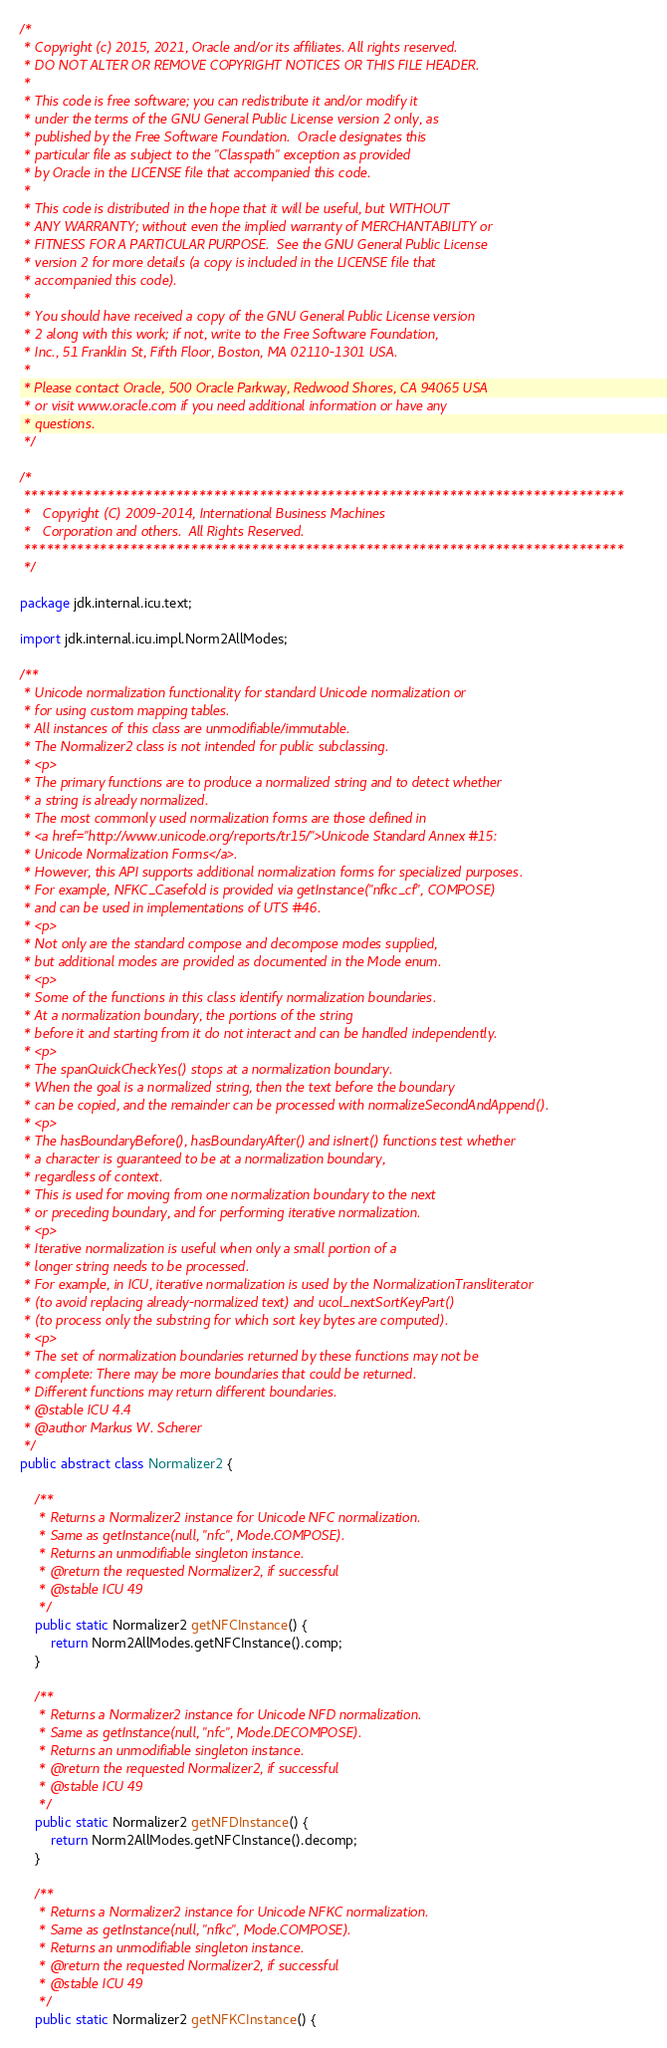Convert code to text. <code><loc_0><loc_0><loc_500><loc_500><_Java_>/*
 * Copyright (c) 2015, 2021, Oracle and/or its affiliates. All rights reserved.
 * DO NOT ALTER OR REMOVE COPYRIGHT NOTICES OR THIS FILE HEADER.
 *
 * This code is free software; you can redistribute it and/or modify it
 * under the terms of the GNU General Public License version 2 only, as
 * published by the Free Software Foundation.  Oracle designates this
 * particular file as subject to the "Classpath" exception as provided
 * by Oracle in the LICENSE file that accompanied this code.
 *
 * This code is distributed in the hope that it will be useful, but WITHOUT
 * ANY WARRANTY; without even the implied warranty of MERCHANTABILITY or
 * FITNESS FOR A PARTICULAR PURPOSE.  See the GNU General Public License
 * version 2 for more details (a copy is included in the LICENSE file that
 * accompanied this code).
 *
 * You should have received a copy of the GNU General Public License version
 * 2 along with this work; if not, write to the Free Software Foundation,
 * Inc., 51 Franklin St, Fifth Floor, Boston, MA 02110-1301 USA.
 *
 * Please contact Oracle, 500 Oracle Parkway, Redwood Shores, CA 94065 USA
 * or visit www.oracle.com if you need additional information or have any
 * questions.
 */

/*
 *******************************************************************************
 *   Copyright (C) 2009-2014, International Business Machines
 *   Corporation and others.  All Rights Reserved.
 *******************************************************************************
 */

package jdk.internal.icu.text;

import jdk.internal.icu.impl.Norm2AllModes;

/**
 * Unicode normalization functionality for standard Unicode normalization or
 * for using custom mapping tables.
 * All instances of this class are unmodifiable/immutable.
 * The Normalizer2 class is not intended for public subclassing.
 * <p>
 * The primary functions are to produce a normalized string and to detect whether
 * a string is already normalized.
 * The most commonly used normalization forms are those defined in
 * <a href="http://www.unicode.org/reports/tr15/">Unicode Standard Annex #15:
 * Unicode Normalization Forms</a>.
 * However, this API supports additional normalization forms for specialized purposes.
 * For example, NFKC_Casefold is provided via getInstance("nfkc_cf", COMPOSE)
 * and can be used in implementations of UTS #46.
 * <p>
 * Not only are the standard compose and decompose modes supplied,
 * but additional modes are provided as documented in the Mode enum.
 * <p>
 * Some of the functions in this class identify normalization boundaries.
 * At a normalization boundary, the portions of the string
 * before it and starting from it do not interact and can be handled independently.
 * <p>
 * The spanQuickCheckYes() stops at a normalization boundary.
 * When the goal is a normalized string, then the text before the boundary
 * can be copied, and the remainder can be processed with normalizeSecondAndAppend().
 * <p>
 * The hasBoundaryBefore(), hasBoundaryAfter() and isInert() functions test whether
 * a character is guaranteed to be at a normalization boundary,
 * regardless of context.
 * This is used for moving from one normalization boundary to the next
 * or preceding boundary, and for performing iterative normalization.
 * <p>
 * Iterative normalization is useful when only a small portion of a
 * longer string needs to be processed.
 * For example, in ICU, iterative normalization is used by the NormalizationTransliterator
 * (to avoid replacing already-normalized text) and ucol_nextSortKeyPart()
 * (to process only the substring for which sort key bytes are computed).
 * <p>
 * The set of normalization boundaries returned by these functions may not be
 * complete: There may be more boundaries that could be returned.
 * Different functions may return different boundaries.
 * @stable ICU 4.4
 * @author Markus W. Scherer
 */
public abstract class Normalizer2 {

    /**
     * Returns a Normalizer2 instance for Unicode NFC normalization.
     * Same as getInstance(null, "nfc", Mode.COMPOSE).
     * Returns an unmodifiable singleton instance.
     * @return the requested Normalizer2, if successful
     * @stable ICU 49
     */
    public static Normalizer2 getNFCInstance() {
        return Norm2AllModes.getNFCInstance().comp;
    }

    /**
     * Returns a Normalizer2 instance for Unicode NFD normalization.
     * Same as getInstance(null, "nfc", Mode.DECOMPOSE).
     * Returns an unmodifiable singleton instance.
     * @return the requested Normalizer2, if successful
     * @stable ICU 49
     */
    public static Normalizer2 getNFDInstance() {
        return Norm2AllModes.getNFCInstance().decomp;
    }

    /**
     * Returns a Normalizer2 instance for Unicode NFKC normalization.
     * Same as getInstance(null, "nfkc", Mode.COMPOSE).
     * Returns an unmodifiable singleton instance.
     * @return the requested Normalizer2, if successful
     * @stable ICU 49
     */
    public static Normalizer2 getNFKCInstance() {</code> 